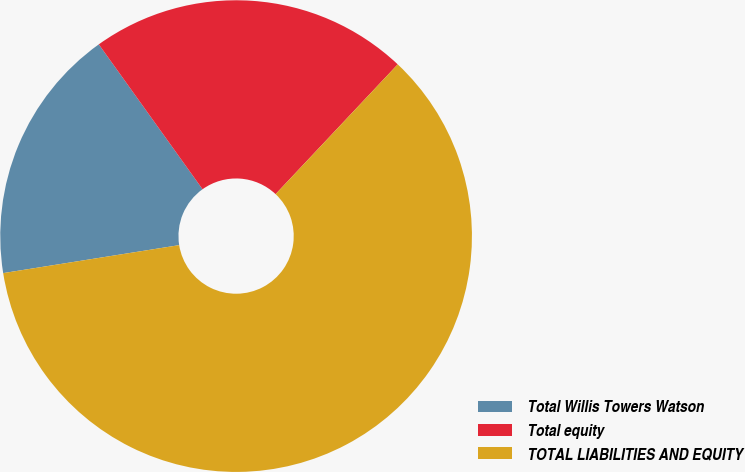Convert chart to OTSL. <chart><loc_0><loc_0><loc_500><loc_500><pie_chart><fcel>Total Willis Towers Watson<fcel>Total equity<fcel>TOTAL LIABILITIES AND EQUITY<nl><fcel>17.62%<fcel>21.91%<fcel>60.48%<nl></chart> 